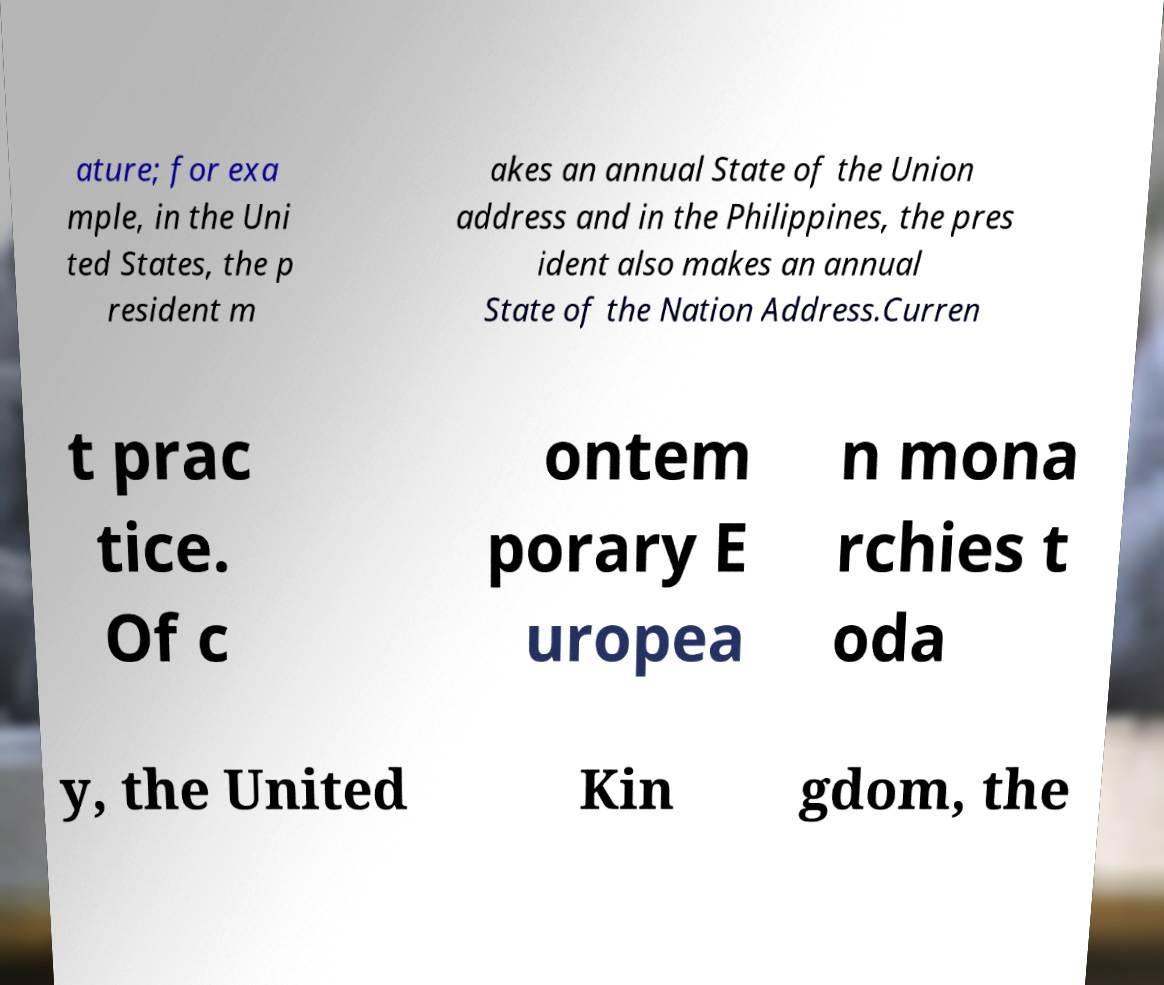There's text embedded in this image that I need extracted. Can you transcribe it verbatim? ature; for exa mple, in the Uni ted States, the p resident m akes an annual State of the Union address and in the Philippines, the pres ident also makes an annual State of the Nation Address.Curren t prac tice. Of c ontem porary E uropea n mona rchies t oda y, the United Kin gdom, the 